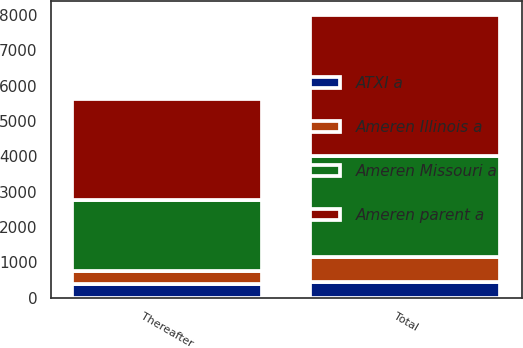<chart> <loc_0><loc_0><loc_500><loc_500><stacked_bar_chart><ecel><fcel>Thereafter<fcel>Total<nl><fcel>Ameren Illinois a<fcel>350<fcel>700<nl><fcel>Ameren parent a<fcel>2867<fcel>3988<nl><fcel>Ameren Missouri a<fcel>2000<fcel>2857<nl><fcel>ATXI a<fcel>400<fcel>450<nl></chart> 